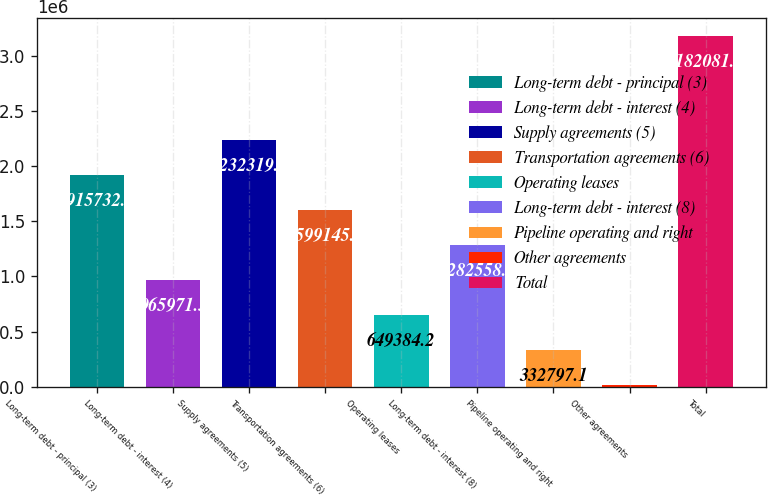Convert chart to OTSL. <chart><loc_0><loc_0><loc_500><loc_500><bar_chart><fcel>Long-term debt - principal (3)<fcel>Long-term debt - interest (4)<fcel>Supply agreements (5)<fcel>Transportation agreements (6)<fcel>Operating leases<fcel>Long-term debt - interest (8)<fcel>Pipeline operating and right<fcel>Other agreements<fcel>Total<nl><fcel>1.91573e+06<fcel>965971<fcel>2.23232e+06<fcel>1.59915e+06<fcel>649384<fcel>1.28256e+06<fcel>332797<fcel>16210<fcel>3.18208e+06<nl></chart> 